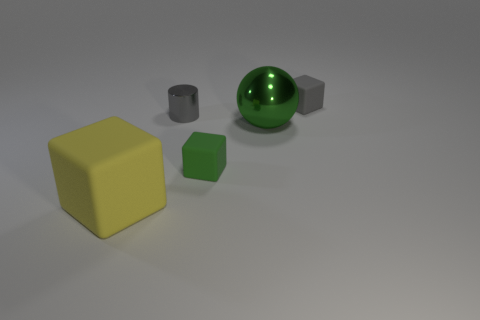Subtract all green matte cubes. How many cubes are left? 2 Add 1 tiny gray metallic cylinders. How many objects exist? 6 Subtract all green blocks. How many blocks are left? 2 Subtract 1 balls. How many balls are left? 0 Subtract all blocks. How many objects are left? 2 Add 4 green matte things. How many green matte things exist? 5 Subtract 0 blue cubes. How many objects are left? 5 Subtract all yellow blocks. Subtract all gray cylinders. How many blocks are left? 2 Subtract all small green things. Subtract all large rubber things. How many objects are left? 3 Add 1 big green metallic objects. How many big green metallic objects are left? 2 